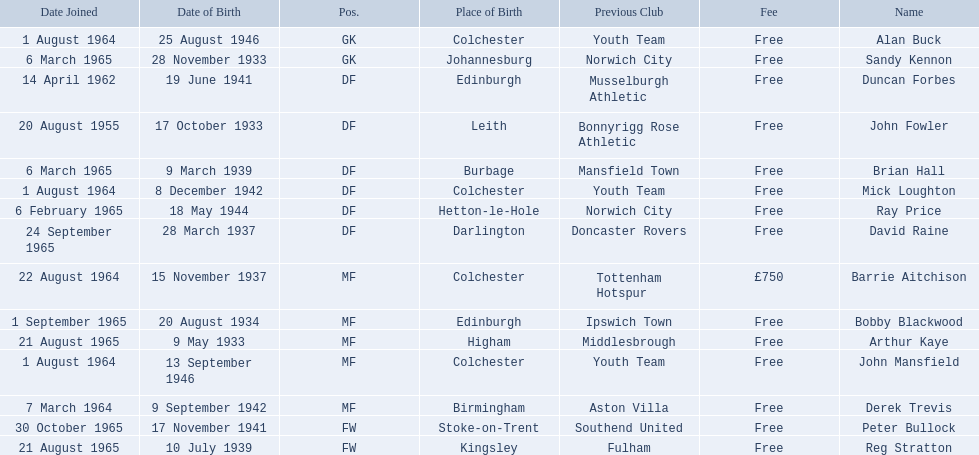Who are all the players? Alan Buck, Sandy Kennon, Duncan Forbes, John Fowler, Brian Hall, Mick Loughton, Ray Price, David Raine, Barrie Aitchison, Bobby Blackwood, Arthur Kaye, John Mansfield, Derek Trevis, Peter Bullock, Reg Stratton. What dates did the players join on? 1 August 1964, 6 March 1965, 14 April 1962, 20 August 1955, 6 March 1965, 1 August 1964, 6 February 1965, 24 September 1965, 22 August 1964, 1 September 1965, 21 August 1965, 1 August 1964, 7 March 1964, 30 October 1965, 21 August 1965. Who is the first player who joined? John Fowler. What is the date of the first person who joined? 20 August 1955. 